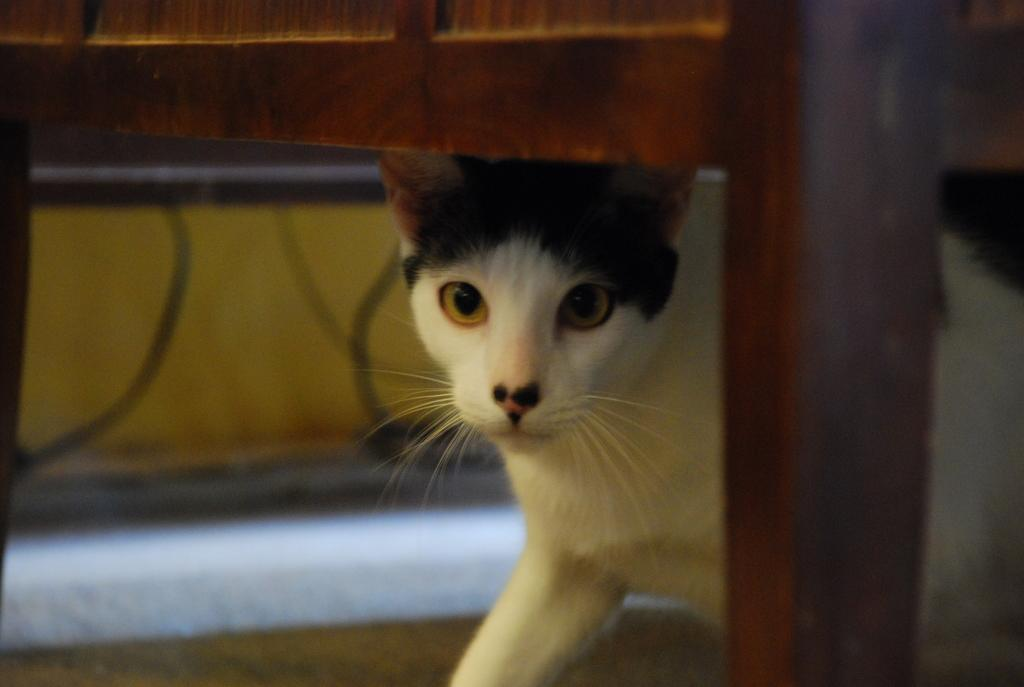What type of seating is visible in the image? There is a wooden frame bench in the image. What animal can be seen in the image? There is a cat in the image. What is the color of the cat? The cat is white in color. Are there any distinct markings on the cat? Yes, the cat has a black part on its head. What is the cat arguing with its friend about in the image? There is no indication of an argument or a friend in the image; it simply shows a white cat with a black part on its head sitting on a wooden frame bench. 